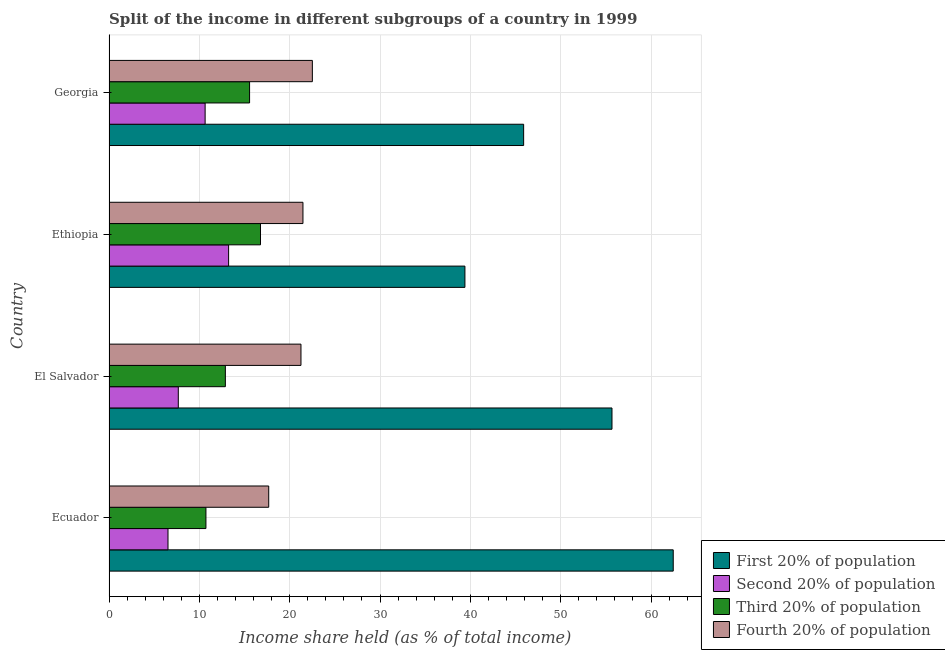Are the number of bars per tick equal to the number of legend labels?
Ensure brevity in your answer.  Yes. How many bars are there on the 1st tick from the top?
Offer a terse response. 4. What is the label of the 3rd group of bars from the top?
Keep it short and to the point. El Salvador. In how many cases, is the number of bars for a given country not equal to the number of legend labels?
Provide a short and direct response. 0. What is the share of the income held by first 20% of the population in Ethiopia?
Ensure brevity in your answer.  39.4. Across all countries, what is the maximum share of the income held by second 20% of the population?
Make the answer very short. 13.24. Across all countries, what is the minimum share of the income held by third 20% of the population?
Make the answer very short. 10.73. In which country was the share of the income held by fourth 20% of the population maximum?
Keep it short and to the point. Georgia. In which country was the share of the income held by second 20% of the population minimum?
Your answer should be compact. Ecuador. What is the total share of the income held by third 20% of the population in the graph?
Provide a short and direct response. 55.94. What is the difference between the share of the income held by first 20% of the population in Ethiopia and that in Georgia?
Make the answer very short. -6.5. What is the difference between the share of the income held by fourth 20% of the population in Ethiopia and the share of the income held by second 20% of the population in El Salvador?
Offer a terse response. 13.8. What is the average share of the income held by fourth 20% of the population per country?
Provide a short and direct response. 20.73. What is the difference between the share of the income held by first 20% of the population and share of the income held by third 20% of the population in Ethiopia?
Your answer should be compact. 22.63. What is the ratio of the share of the income held by fourth 20% of the population in Ecuador to that in El Salvador?
Ensure brevity in your answer.  0.83. Is the share of the income held by third 20% of the population in El Salvador less than that in Ethiopia?
Your answer should be very brief. Yes. Is the difference between the share of the income held by second 20% of the population in Ecuador and El Salvador greater than the difference between the share of the income held by third 20% of the population in Ecuador and El Salvador?
Ensure brevity in your answer.  Yes. What is the difference between the highest and the second highest share of the income held by third 20% of the population?
Ensure brevity in your answer.  1.21. What is the difference between the highest and the lowest share of the income held by second 20% of the population?
Provide a short and direct response. 6.71. Is the sum of the share of the income held by first 20% of the population in Ecuador and El Salvador greater than the maximum share of the income held by third 20% of the population across all countries?
Make the answer very short. Yes. What does the 1st bar from the top in Ecuador represents?
Give a very brief answer. Fourth 20% of population. What does the 3rd bar from the bottom in Ecuador represents?
Provide a succinct answer. Third 20% of population. How many bars are there?
Provide a short and direct response. 16. Are all the bars in the graph horizontal?
Give a very brief answer. Yes. Does the graph contain any zero values?
Provide a short and direct response. No. How many legend labels are there?
Offer a terse response. 4. What is the title of the graph?
Make the answer very short. Split of the income in different subgroups of a country in 1999. What is the label or title of the X-axis?
Your response must be concise. Income share held (as % of total income). What is the Income share held (as % of total income) in First 20% of population in Ecuador?
Provide a short and direct response. 62.46. What is the Income share held (as % of total income) of Second 20% of population in Ecuador?
Offer a very short reply. 6.53. What is the Income share held (as % of total income) in Third 20% of population in Ecuador?
Ensure brevity in your answer.  10.73. What is the Income share held (as % of total income) of Fourth 20% of population in Ecuador?
Offer a terse response. 17.68. What is the Income share held (as % of total income) in First 20% of population in El Salvador?
Ensure brevity in your answer.  55.68. What is the Income share held (as % of total income) of Second 20% of population in El Salvador?
Provide a succinct answer. 7.67. What is the Income share held (as % of total income) in Third 20% of population in El Salvador?
Provide a succinct answer. 12.88. What is the Income share held (as % of total income) of Fourth 20% of population in El Salvador?
Offer a terse response. 21.25. What is the Income share held (as % of total income) of First 20% of population in Ethiopia?
Provide a succinct answer. 39.4. What is the Income share held (as % of total income) of Second 20% of population in Ethiopia?
Offer a terse response. 13.24. What is the Income share held (as % of total income) of Third 20% of population in Ethiopia?
Ensure brevity in your answer.  16.77. What is the Income share held (as % of total income) of Fourth 20% of population in Ethiopia?
Your response must be concise. 21.47. What is the Income share held (as % of total income) in First 20% of population in Georgia?
Offer a very short reply. 45.9. What is the Income share held (as % of total income) in Second 20% of population in Georgia?
Your response must be concise. 10.64. What is the Income share held (as % of total income) in Third 20% of population in Georgia?
Make the answer very short. 15.56. What is the Income share held (as % of total income) of Fourth 20% of population in Georgia?
Make the answer very short. 22.51. Across all countries, what is the maximum Income share held (as % of total income) in First 20% of population?
Ensure brevity in your answer.  62.46. Across all countries, what is the maximum Income share held (as % of total income) in Second 20% of population?
Offer a terse response. 13.24. Across all countries, what is the maximum Income share held (as % of total income) of Third 20% of population?
Provide a succinct answer. 16.77. Across all countries, what is the maximum Income share held (as % of total income) in Fourth 20% of population?
Your answer should be compact. 22.51. Across all countries, what is the minimum Income share held (as % of total income) of First 20% of population?
Offer a terse response. 39.4. Across all countries, what is the minimum Income share held (as % of total income) in Second 20% of population?
Your response must be concise. 6.53. Across all countries, what is the minimum Income share held (as % of total income) of Third 20% of population?
Your answer should be compact. 10.73. Across all countries, what is the minimum Income share held (as % of total income) of Fourth 20% of population?
Provide a short and direct response. 17.68. What is the total Income share held (as % of total income) of First 20% of population in the graph?
Make the answer very short. 203.44. What is the total Income share held (as % of total income) in Second 20% of population in the graph?
Ensure brevity in your answer.  38.08. What is the total Income share held (as % of total income) in Third 20% of population in the graph?
Keep it short and to the point. 55.94. What is the total Income share held (as % of total income) in Fourth 20% of population in the graph?
Your response must be concise. 82.91. What is the difference between the Income share held (as % of total income) of First 20% of population in Ecuador and that in El Salvador?
Make the answer very short. 6.78. What is the difference between the Income share held (as % of total income) of Second 20% of population in Ecuador and that in El Salvador?
Your answer should be very brief. -1.14. What is the difference between the Income share held (as % of total income) in Third 20% of population in Ecuador and that in El Salvador?
Ensure brevity in your answer.  -2.15. What is the difference between the Income share held (as % of total income) in Fourth 20% of population in Ecuador and that in El Salvador?
Your answer should be very brief. -3.57. What is the difference between the Income share held (as % of total income) of First 20% of population in Ecuador and that in Ethiopia?
Your answer should be compact. 23.06. What is the difference between the Income share held (as % of total income) in Second 20% of population in Ecuador and that in Ethiopia?
Provide a short and direct response. -6.71. What is the difference between the Income share held (as % of total income) in Third 20% of population in Ecuador and that in Ethiopia?
Offer a very short reply. -6.04. What is the difference between the Income share held (as % of total income) of Fourth 20% of population in Ecuador and that in Ethiopia?
Your answer should be very brief. -3.79. What is the difference between the Income share held (as % of total income) of First 20% of population in Ecuador and that in Georgia?
Give a very brief answer. 16.56. What is the difference between the Income share held (as % of total income) in Second 20% of population in Ecuador and that in Georgia?
Your response must be concise. -4.11. What is the difference between the Income share held (as % of total income) in Third 20% of population in Ecuador and that in Georgia?
Your response must be concise. -4.83. What is the difference between the Income share held (as % of total income) of Fourth 20% of population in Ecuador and that in Georgia?
Provide a short and direct response. -4.83. What is the difference between the Income share held (as % of total income) of First 20% of population in El Salvador and that in Ethiopia?
Offer a very short reply. 16.28. What is the difference between the Income share held (as % of total income) in Second 20% of population in El Salvador and that in Ethiopia?
Offer a very short reply. -5.57. What is the difference between the Income share held (as % of total income) of Third 20% of population in El Salvador and that in Ethiopia?
Provide a short and direct response. -3.89. What is the difference between the Income share held (as % of total income) of Fourth 20% of population in El Salvador and that in Ethiopia?
Offer a very short reply. -0.22. What is the difference between the Income share held (as % of total income) of First 20% of population in El Salvador and that in Georgia?
Provide a succinct answer. 9.78. What is the difference between the Income share held (as % of total income) of Second 20% of population in El Salvador and that in Georgia?
Your answer should be very brief. -2.97. What is the difference between the Income share held (as % of total income) of Third 20% of population in El Salvador and that in Georgia?
Give a very brief answer. -2.68. What is the difference between the Income share held (as % of total income) in Fourth 20% of population in El Salvador and that in Georgia?
Provide a short and direct response. -1.26. What is the difference between the Income share held (as % of total income) of First 20% of population in Ethiopia and that in Georgia?
Make the answer very short. -6.5. What is the difference between the Income share held (as % of total income) in Third 20% of population in Ethiopia and that in Georgia?
Make the answer very short. 1.21. What is the difference between the Income share held (as % of total income) in Fourth 20% of population in Ethiopia and that in Georgia?
Give a very brief answer. -1.04. What is the difference between the Income share held (as % of total income) in First 20% of population in Ecuador and the Income share held (as % of total income) in Second 20% of population in El Salvador?
Provide a short and direct response. 54.79. What is the difference between the Income share held (as % of total income) of First 20% of population in Ecuador and the Income share held (as % of total income) of Third 20% of population in El Salvador?
Your answer should be very brief. 49.58. What is the difference between the Income share held (as % of total income) of First 20% of population in Ecuador and the Income share held (as % of total income) of Fourth 20% of population in El Salvador?
Make the answer very short. 41.21. What is the difference between the Income share held (as % of total income) of Second 20% of population in Ecuador and the Income share held (as % of total income) of Third 20% of population in El Salvador?
Keep it short and to the point. -6.35. What is the difference between the Income share held (as % of total income) in Second 20% of population in Ecuador and the Income share held (as % of total income) in Fourth 20% of population in El Salvador?
Make the answer very short. -14.72. What is the difference between the Income share held (as % of total income) in Third 20% of population in Ecuador and the Income share held (as % of total income) in Fourth 20% of population in El Salvador?
Keep it short and to the point. -10.52. What is the difference between the Income share held (as % of total income) in First 20% of population in Ecuador and the Income share held (as % of total income) in Second 20% of population in Ethiopia?
Your response must be concise. 49.22. What is the difference between the Income share held (as % of total income) of First 20% of population in Ecuador and the Income share held (as % of total income) of Third 20% of population in Ethiopia?
Keep it short and to the point. 45.69. What is the difference between the Income share held (as % of total income) in First 20% of population in Ecuador and the Income share held (as % of total income) in Fourth 20% of population in Ethiopia?
Offer a very short reply. 40.99. What is the difference between the Income share held (as % of total income) of Second 20% of population in Ecuador and the Income share held (as % of total income) of Third 20% of population in Ethiopia?
Make the answer very short. -10.24. What is the difference between the Income share held (as % of total income) of Second 20% of population in Ecuador and the Income share held (as % of total income) of Fourth 20% of population in Ethiopia?
Your answer should be very brief. -14.94. What is the difference between the Income share held (as % of total income) of Third 20% of population in Ecuador and the Income share held (as % of total income) of Fourth 20% of population in Ethiopia?
Your answer should be compact. -10.74. What is the difference between the Income share held (as % of total income) of First 20% of population in Ecuador and the Income share held (as % of total income) of Second 20% of population in Georgia?
Ensure brevity in your answer.  51.82. What is the difference between the Income share held (as % of total income) in First 20% of population in Ecuador and the Income share held (as % of total income) in Third 20% of population in Georgia?
Ensure brevity in your answer.  46.9. What is the difference between the Income share held (as % of total income) in First 20% of population in Ecuador and the Income share held (as % of total income) in Fourth 20% of population in Georgia?
Your answer should be very brief. 39.95. What is the difference between the Income share held (as % of total income) in Second 20% of population in Ecuador and the Income share held (as % of total income) in Third 20% of population in Georgia?
Offer a very short reply. -9.03. What is the difference between the Income share held (as % of total income) in Second 20% of population in Ecuador and the Income share held (as % of total income) in Fourth 20% of population in Georgia?
Ensure brevity in your answer.  -15.98. What is the difference between the Income share held (as % of total income) in Third 20% of population in Ecuador and the Income share held (as % of total income) in Fourth 20% of population in Georgia?
Ensure brevity in your answer.  -11.78. What is the difference between the Income share held (as % of total income) of First 20% of population in El Salvador and the Income share held (as % of total income) of Second 20% of population in Ethiopia?
Offer a terse response. 42.44. What is the difference between the Income share held (as % of total income) in First 20% of population in El Salvador and the Income share held (as % of total income) in Third 20% of population in Ethiopia?
Offer a very short reply. 38.91. What is the difference between the Income share held (as % of total income) of First 20% of population in El Salvador and the Income share held (as % of total income) of Fourth 20% of population in Ethiopia?
Ensure brevity in your answer.  34.21. What is the difference between the Income share held (as % of total income) in Third 20% of population in El Salvador and the Income share held (as % of total income) in Fourth 20% of population in Ethiopia?
Your answer should be very brief. -8.59. What is the difference between the Income share held (as % of total income) in First 20% of population in El Salvador and the Income share held (as % of total income) in Second 20% of population in Georgia?
Provide a succinct answer. 45.04. What is the difference between the Income share held (as % of total income) of First 20% of population in El Salvador and the Income share held (as % of total income) of Third 20% of population in Georgia?
Offer a very short reply. 40.12. What is the difference between the Income share held (as % of total income) of First 20% of population in El Salvador and the Income share held (as % of total income) of Fourth 20% of population in Georgia?
Provide a short and direct response. 33.17. What is the difference between the Income share held (as % of total income) of Second 20% of population in El Salvador and the Income share held (as % of total income) of Third 20% of population in Georgia?
Offer a terse response. -7.89. What is the difference between the Income share held (as % of total income) of Second 20% of population in El Salvador and the Income share held (as % of total income) of Fourth 20% of population in Georgia?
Ensure brevity in your answer.  -14.84. What is the difference between the Income share held (as % of total income) of Third 20% of population in El Salvador and the Income share held (as % of total income) of Fourth 20% of population in Georgia?
Provide a succinct answer. -9.63. What is the difference between the Income share held (as % of total income) in First 20% of population in Ethiopia and the Income share held (as % of total income) in Second 20% of population in Georgia?
Offer a very short reply. 28.76. What is the difference between the Income share held (as % of total income) in First 20% of population in Ethiopia and the Income share held (as % of total income) in Third 20% of population in Georgia?
Offer a very short reply. 23.84. What is the difference between the Income share held (as % of total income) in First 20% of population in Ethiopia and the Income share held (as % of total income) in Fourth 20% of population in Georgia?
Give a very brief answer. 16.89. What is the difference between the Income share held (as % of total income) in Second 20% of population in Ethiopia and the Income share held (as % of total income) in Third 20% of population in Georgia?
Give a very brief answer. -2.32. What is the difference between the Income share held (as % of total income) in Second 20% of population in Ethiopia and the Income share held (as % of total income) in Fourth 20% of population in Georgia?
Your answer should be compact. -9.27. What is the difference between the Income share held (as % of total income) of Third 20% of population in Ethiopia and the Income share held (as % of total income) of Fourth 20% of population in Georgia?
Offer a very short reply. -5.74. What is the average Income share held (as % of total income) of First 20% of population per country?
Keep it short and to the point. 50.86. What is the average Income share held (as % of total income) in Second 20% of population per country?
Your response must be concise. 9.52. What is the average Income share held (as % of total income) of Third 20% of population per country?
Keep it short and to the point. 13.98. What is the average Income share held (as % of total income) of Fourth 20% of population per country?
Your answer should be very brief. 20.73. What is the difference between the Income share held (as % of total income) of First 20% of population and Income share held (as % of total income) of Second 20% of population in Ecuador?
Provide a succinct answer. 55.93. What is the difference between the Income share held (as % of total income) of First 20% of population and Income share held (as % of total income) of Third 20% of population in Ecuador?
Your answer should be compact. 51.73. What is the difference between the Income share held (as % of total income) in First 20% of population and Income share held (as % of total income) in Fourth 20% of population in Ecuador?
Your answer should be compact. 44.78. What is the difference between the Income share held (as % of total income) in Second 20% of population and Income share held (as % of total income) in Third 20% of population in Ecuador?
Your response must be concise. -4.2. What is the difference between the Income share held (as % of total income) in Second 20% of population and Income share held (as % of total income) in Fourth 20% of population in Ecuador?
Make the answer very short. -11.15. What is the difference between the Income share held (as % of total income) of Third 20% of population and Income share held (as % of total income) of Fourth 20% of population in Ecuador?
Your answer should be compact. -6.95. What is the difference between the Income share held (as % of total income) in First 20% of population and Income share held (as % of total income) in Second 20% of population in El Salvador?
Provide a succinct answer. 48.01. What is the difference between the Income share held (as % of total income) of First 20% of population and Income share held (as % of total income) of Third 20% of population in El Salvador?
Ensure brevity in your answer.  42.8. What is the difference between the Income share held (as % of total income) in First 20% of population and Income share held (as % of total income) in Fourth 20% of population in El Salvador?
Your answer should be compact. 34.43. What is the difference between the Income share held (as % of total income) in Second 20% of population and Income share held (as % of total income) in Third 20% of population in El Salvador?
Provide a short and direct response. -5.21. What is the difference between the Income share held (as % of total income) of Second 20% of population and Income share held (as % of total income) of Fourth 20% of population in El Salvador?
Ensure brevity in your answer.  -13.58. What is the difference between the Income share held (as % of total income) of Third 20% of population and Income share held (as % of total income) of Fourth 20% of population in El Salvador?
Provide a short and direct response. -8.37. What is the difference between the Income share held (as % of total income) in First 20% of population and Income share held (as % of total income) in Second 20% of population in Ethiopia?
Your response must be concise. 26.16. What is the difference between the Income share held (as % of total income) of First 20% of population and Income share held (as % of total income) of Third 20% of population in Ethiopia?
Your response must be concise. 22.63. What is the difference between the Income share held (as % of total income) in First 20% of population and Income share held (as % of total income) in Fourth 20% of population in Ethiopia?
Ensure brevity in your answer.  17.93. What is the difference between the Income share held (as % of total income) in Second 20% of population and Income share held (as % of total income) in Third 20% of population in Ethiopia?
Your answer should be very brief. -3.53. What is the difference between the Income share held (as % of total income) in Second 20% of population and Income share held (as % of total income) in Fourth 20% of population in Ethiopia?
Provide a succinct answer. -8.23. What is the difference between the Income share held (as % of total income) of Third 20% of population and Income share held (as % of total income) of Fourth 20% of population in Ethiopia?
Give a very brief answer. -4.7. What is the difference between the Income share held (as % of total income) in First 20% of population and Income share held (as % of total income) in Second 20% of population in Georgia?
Ensure brevity in your answer.  35.26. What is the difference between the Income share held (as % of total income) in First 20% of population and Income share held (as % of total income) in Third 20% of population in Georgia?
Your answer should be compact. 30.34. What is the difference between the Income share held (as % of total income) in First 20% of population and Income share held (as % of total income) in Fourth 20% of population in Georgia?
Give a very brief answer. 23.39. What is the difference between the Income share held (as % of total income) of Second 20% of population and Income share held (as % of total income) of Third 20% of population in Georgia?
Keep it short and to the point. -4.92. What is the difference between the Income share held (as % of total income) in Second 20% of population and Income share held (as % of total income) in Fourth 20% of population in Georgia?
Keep it short and to the point. -11.87. What is the difference between the Income share held (as % of total income) in Third 20% of population and Income share held (as % of total income) in Fourth 20% of population in Georgia?
Offer a very short reply. -6.95. What is the ratio of the Income share held (as % of total income) in First 20% of population in Ecuador to that in El Salvador?
Ensure brevity in your answer.  1.12. What is the ratio of the Income share held (as % of total income) of Second 20% of population in Ecuador to that in El Salvador?
Provide a short and direct response. 0.85. What is the ratio of the Income share held (as % of total income) in Third 20% of population in Ecuador to that in El Salvador?
Your response must be concise. 0.83. What is the ratio of the Income share held (as % of total income) of Fourth 20% of population in Ecuador to that in El Salvador?
Your answer should be very brief. 0.83. What is the ratio of the Income share held (as % of total income) of First 20% of population in Ecuador to that in Ethiopia?
Offer a terse response. 1.59. What is the ratio of the Income share held (as % of total income) of Second 20% of population in Ecuador to that in Ethiopia?
Offer a very short reply. 0.49. What is the ratio of the Income share held (as % of total income) of Third 20% of population in Ecuador to that in Ethiopia?
Give a very brief answer. 0.64. What is the ratio of the Income share held (as % of total income) in Fourth 20% of population in Ecuador to that in Ethiopia?
Your response must be concise. 0.82. What is the ratio of the Income share held (as % of total income) of First 20% of population in Ecuador to that in Georgia?
Your answer should be very brief. 1.36. What is the ratio of the Income share held (as % of total income) of Second 20% of population in Ecuador to that in Georgia?
Your answer should be very brief. 0.61. What is the ratio of the Income share held (as % of total income) in Third 20% of population in Ecuador to that in Georgia?
Your response must be concise. 0.69. What is the ratio of the Income share held (as % of total income) in Fourth 20% of population in Ecuador to that in Georgia?
Keep it short and to the point. 0.79. What is the ratio of the Income share held (as % of total income) of First 20% of population in El Salvador to that in Ethiopia?
Your answer should be compact. 1.41. What is the ratio of the Income share held (as % of total income) of Second 20% of population in El Salvador to that in Ethiopia?
Your response must be concise. 0.58. What is the ratio of the Income share held (as % of total income) in Third 20% of population in El Salvador to that in Ethiopia?
Offer a very short reply. 0.77. What is the ratio of the Income share held (as % of total income) in Fourth 20% of population in El Salvador to that in Ethiopia?
Keep it short and to the point. 0.99. What is the ratio of the Income share held (as % of total income) in First 20% of population in El Salvador to that in Georgia?
Give a very brief answer. 1.21. What is the ratio of the Income share held (as % of total income) in Second 20% of population in El Salvador to that in Georgia?
Give a very brief answer. 0.72. What is the ratio of the Income share held (as % of total income) in Third 20% of population in El Salvador to that in Georgia?
Give a very brief answer. 0.83. What is the ratio of the Income share held (as % of total income) of Fourth 20% of population in El Salvador to that in Georgia?
Provide a succinct answer. 0.94. What is the ratio of the Income share held (as % of total income) of First 20% of population in Ethiopia to that in Georgia?
Provide a short and direct response. 0.86. What is the ratio of the Income share held (as % of total income) in Second 20% of population in Ethiopia to that in Georgia?
Your response must be concise. 1.24. What is the ratio of the Income share held (as % of total income) in Third 20% of population in Ethiopia to that in Georgia?
Keep it short and to the point. 1.08. What is the ratio of the Income share held (as % of total income) of Fourth 20% of population in Ethiopia to that in Georgia?
Your answer should be compact. 0.95. What is the difference between the highest and the second highest Income share held (as % of total income) in First 20% of population?
Keep it short and to the point. 6.78. What is the difference between the highest and the second highest Income share held (as % of total income) of Second 20% of population?
Ensure brevity in your answer.  2.6. What is the difference between the highest and the second highest Income share held (as % of total income) in Third 20% of population?
Offer a very short reply. 1.21. What is the difference between the highest and the lowest Income share held (as % of total income) in First 20% of population?
Keep it short and to the point. 23.06. What is the difference between the highest and the lowest Income share held (as % of total income) of Second 20% of population?
Ensure brevity in your answer.  6.71. What is the difference between the highest and the lowest Income share held (as % of total income) in Third 20% of population?
Offer a very short reply. 6.04. What is the difference between the highest and the lowest Income share held (as % of total income) of Fourth 20% of population?
Offer a very short reply. 4.83. 